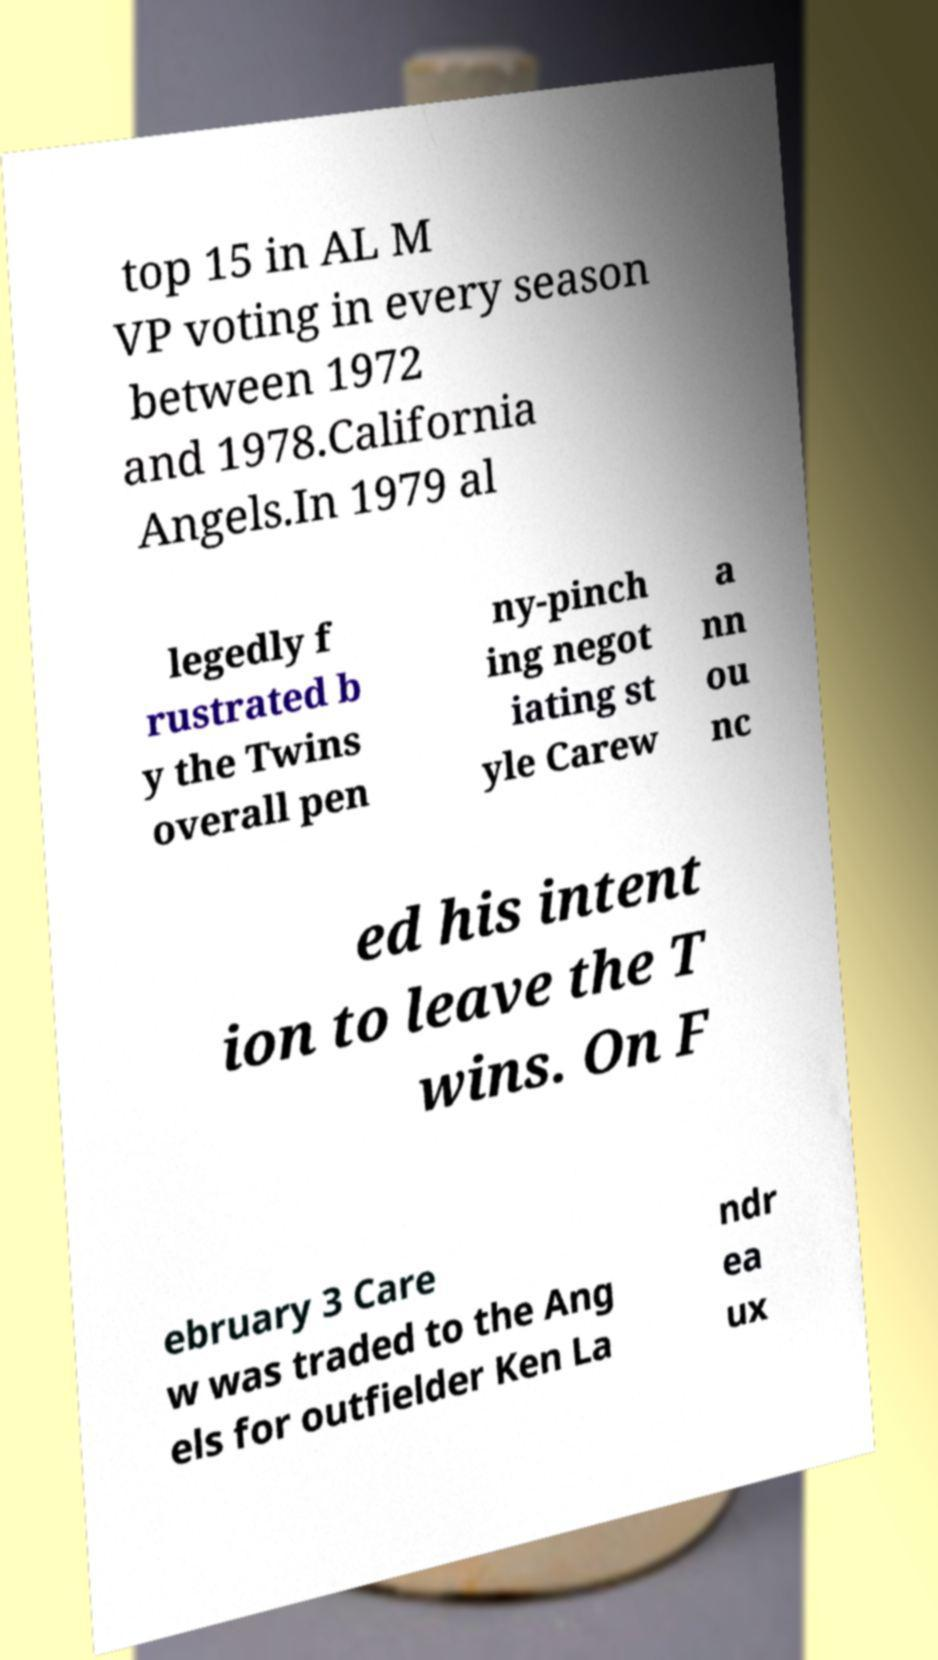Please identify and transcribe the text found in this image. top 15 in AL M VP voting in every season between 1972 and 1978.California Angels.In 1979 al legedly f rustrated b y the Twins overall pen ny-pinch ing negot iating st yle Carew a nn ou nc ed his intent ion to leave the T wins. On F ebruary 3 Care w was traded to the Ang els for outfielder Ken La ndr ea ux 